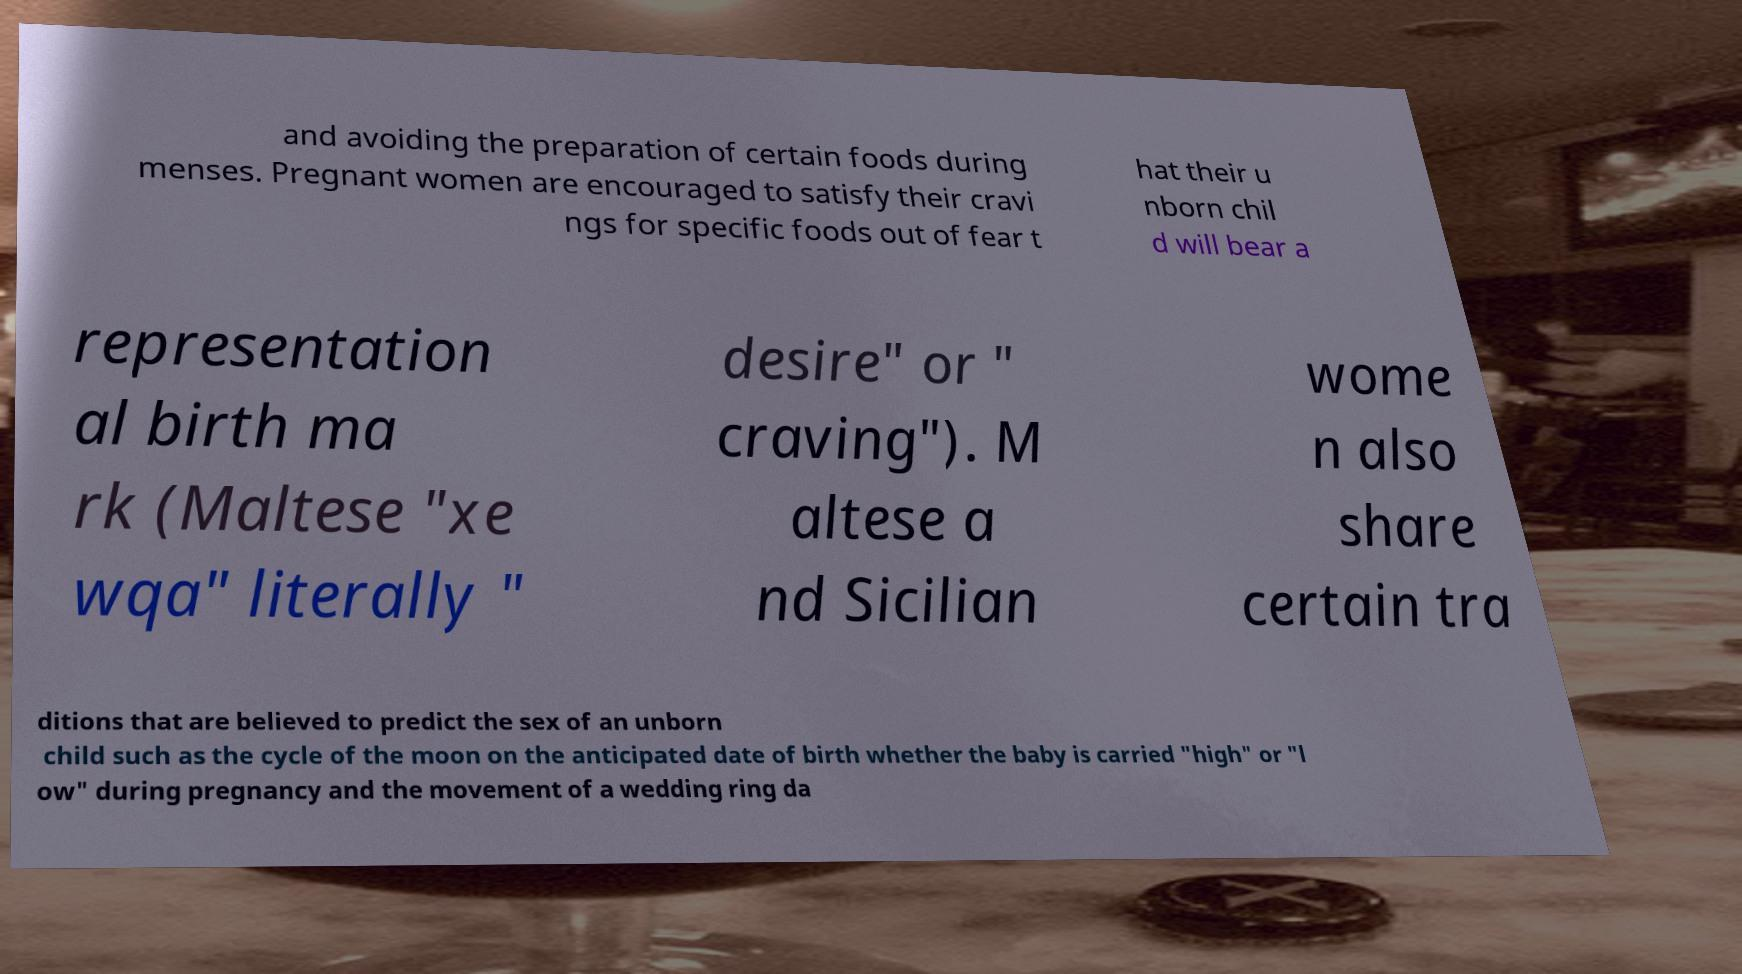What messages or text are displayed in this image? I need them in a readable, typed format. and avoiding the preparation of certain foods during menses. Pregnant women are encouraged to satisfy their cravi ngs for specific foods out of fear t hat their u nborn chil d will bear a representation al birth ma rk (Maltese "xe wqa" literally " desire" or " craving"). M altese a nd Sicilian wome n also share certain tra ditions that are believed to predict the sex of an unborn child such as the cycle of the moon on the anticipated date of birth whether the baby is carried "high" or "l ow" during pregnancy and the movement of a wedding ring da 